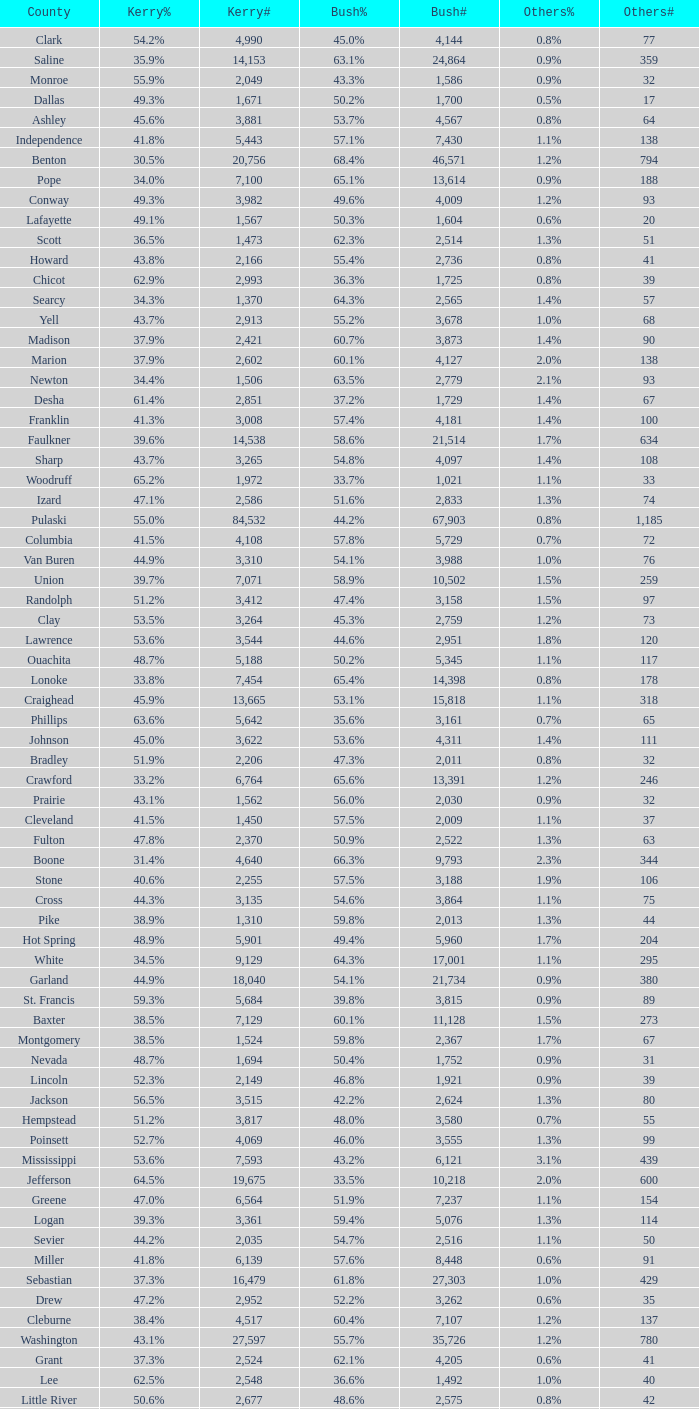What is the highest Bush#, when Others% is "1.7%", when Others# is less than 75, and when Kerry# is greater than 1,524? None. 